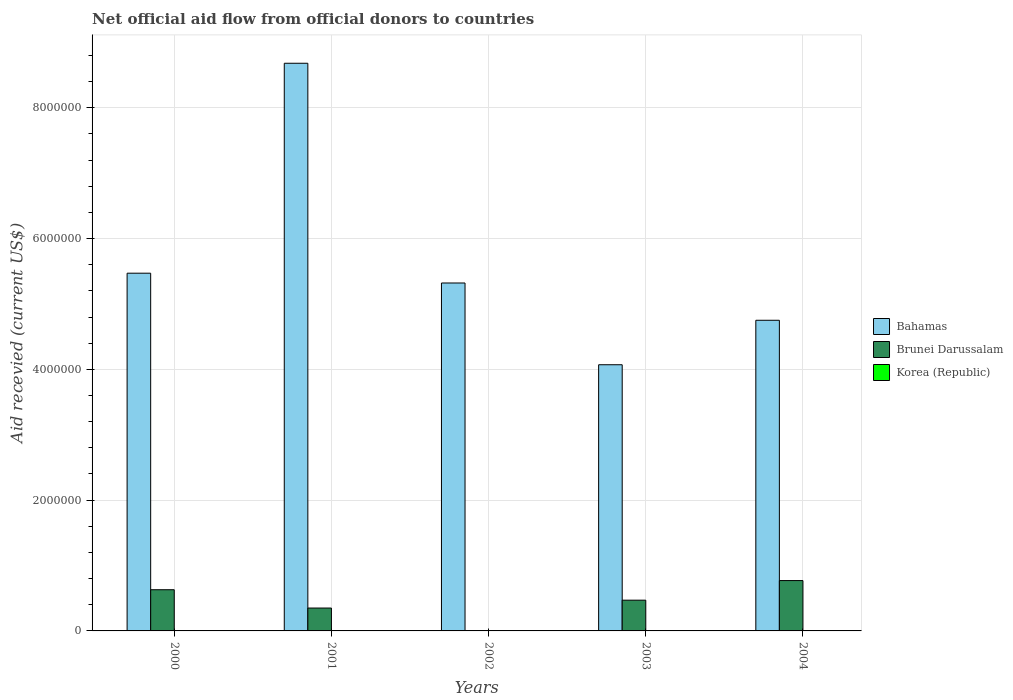How many different coloured bars are there?
Offer a very short reply. 2. Are the number of bars on each tick of the X-axis equal?
Provide a short and direct response. No. How many bars are there on the 1st tick from the left?
Your answer should be very brief. 2. How many bars are there on the 4th tick from the right?
Give a very brief answer. 2. What is the label of the 2nd group of bars from the left?
Your answer should be very brief. 2001. In how many cases, is the number of bars for a given year not equal to the number of legend labels?
Offer a very short reply. 5. What is the total aid received in Korea (Republic) in 2000?
Your answer should be compact. 0. Across all years, what is the maximum total aid received in Bahamas?
Offer a very short reply. 8.68e+06. In which year was the total aid received in Bahamas maximum?
Offer a very short reply. 2001. What is the total total aid received in Korea (Republic) in the graph?
Provide a succinct answer. 0. What is the difference between the total aid received in Korea (Republic) in 2003 and the total aid received in Brunei Darussalam in 2004?
Your answer should be very brief. -7.70e+05. What is the average total aid received in Korea (Republic) per year?
Give a very brief answer. 0. What is the ratio of the total aid received in Brunei Darussalam in 2000 to that in 2001?
Keep it short and to the point. 1.8. Is the total aid received in Bahamas in 2002 less than that in 2003?
Ensure brevity in your answer.  No. Is the difference between the total aid received in Brunei Darussalam in 2001 and 2004 greater than the difference between the total aid received in Bahamas in 2001 and 2004?
Give a very brief answer. No. What is the difference between the highest and the second highest total aid received in Bahamas?
Your response must be concise. 3.21e+06. What is the difference between the highest and the lowest total aid received in Bahamas?
Offer a very short reply. 4.61e+06. In how many years, is the total aid received in Brunei Darussalam greater than the average total aid received in Brunei Darussalam taken over all years?
Offer a very short reply. 3. Is the sum of the total aid received in Bahamas in 2002 and 2004 greater than the maximum total aid received in Korea (Republic) across all years?
Make the answer very short. Yes. Are all the bars in the graph horizontal?
Provide a short and direct response. No. How many years are there in the graph?
Give a very brief answer. 5. Does the graph contain any zero values?
Ensure brevity in your answer.  Yes. Does the graph contain grids?
Offer a terse response. Yes. How are the legend labels stacked?
Your answer should be very brief. Vertical. What is the title of the graph?
Offer a very short reply. Net official aid flow from official donors to countries. Does "Tuvalu" appear as one of the legend labels in the graph?
Your answer should be very brief. No. What is the label or title of the X-axis?
Offer a terse response. Years. What is the label or title of the Y-axis?
Make the answer very short. Aid recevied (current US$). What is the Aid recevied (current US$) of Bahamas in 2000?
Ensure brevity in your answer.  5.47e+06. What is the Aid recevied (current US$) of Brunei Darussalam in 2000?
Your answer should be compact. 6.30e+05. What is the Aid recevied (current US$) of Bahamas in 2001?
Ensure brevity in your answer.  8.68e+06. What is the Aid recevied (current US$) of Brunei Darussalam in 2001?
Make the answer very short. 3.50e+05. What is the Aid recevied (current US$) in Korea (Republic) in 2001?
Make the answer very short. 0. What is the Aid recevied (current US$) of Bahamas in 2002?
Offer a very short reply. 5.32e+06. What is the Aid recevied (current US$) of Korea (Republic) in 2002?
Your answer should be compact. 0. What is the Aid recevied (current US$) of Bahamas in 2003?
Offer a very short reply. 4.07e+06. What is the Aid recevied (current US$) in Korea (Republic) in 2003?
Give a very brief answer. 0. What is the Aid recevied (current US$) in Bahamas in 2004?
Provide a short and direct response. 4.75e+06. What is the Aid recevied (current US$) of Brunei Darussalam in 2004?
Your answer should be compact. 7.70e+05. What is the Aid recevied (current US$) in Korea (Republic) in 2004?
Offer a terse response. 0. Across all years, what is the maximum Aid recevied (current US$) of Bahamas?
Offer a terse response. 8.68e+06. Across all years, what is the maximum Aid recevied (current US$) of Brunei Darussalam?
Your answer should be very brief. 7.70e+05. Across all years, what is the minimum Aid recevied (current US$) in Bahamas?
Give a very brief answer. 4.07e+06. Across all years, what is the minimum Aid recevied (current US$) of Brunei Darussalam?
Your answer should be compact. 0. What is the total Aid recevied (current US$) of Bahamas in the graph?
Ensure brevity in your answer.  2.83e+07. What is the total Aid recevied (current US$) in Brunei Darussalam in the graph?
Your response must be concise. 2.22e+06. What is the total Aid recevied (current US$) in Korea (Republic) in the graph?
Your answer should be compact. 0. What is the difference between the Aid recevied (current US$) of Bahamas in 2000 and that in 2001?
Make the answer very short. -3.21e+06. What is the difference between the Aid recevied (current US$) of Bahamas in 2000 and that in 2002?
Keep it short and to the point. 1.50e+05. What is the difference between the Aid recevied (current US$) of Bahamas in 2000 and that in 2003?
Your response must be concise. 1.40e+06. What is the difference between the Aid recevied (current US$) of Brunei Darussalam in 2000 and that in 2003?
Offer a terse response. 1.60e+05. What is the difference between the Aid recevied (current US$) in Bahamas in 2000 and that in 2004?
Make the answer very short. 7.20e+05. What is the difference between the Aid recevied (current US$) of Brunei Darussalam in 2000 and that in 2004?
Your response must be concise. -1.40e+05. What is the difference between the Aid recevied (current US$) in Bahamas in 2001 and that in 2002?
Provide a succinct answer. 3.36e+06. What is the difference between the Aid recevied (current US$) in Bahamas in 2001 and that in 2003?
Provide a succinct answer. 4.61e+06. What is the difference between the Aid recevied (current US$) in Brunei Darussalam in 2001 and that in 2003?
Offer a terse response. -1.20e+05. What is the difference between the Aid recevied (current US$) of Bahamas in 2001 and that in 2004?
Provide a short and direct response. 3.93e+06. What is the difference between the Aid recevied (current US$) in Brunei Darussalam in 2001 and that in 2004?
Offer a very short reply. -4.20e+05. What is the difference between the Aid recevied (current US$) of Bahamas in 2002 and that in 2003?
Provide a succinct answer. 1.25e+06. What is the difference between the Aid recevied (current US$) of Bahamas in 2002 and that in 2004?
Ensure brevity in your answer.  5.70e+05. What is the difference between the Aid recevied (current US$) of Bahamas in 2003 and that in 2004?
Provide a short and direct response. -6.80e+05. What is the difference between the Aid recevied (current US$) of Bahamas in 2000 and the Aid recevied (current US$) of Brunei Darussalam in 2001?
Ensure brevity in your answer.  5.12e+06. What is the difference between the Aid recevied (current US$) in Bahamas in 2000 and the Aid recevied (current US$) in Brunei Darussalam in 2004?
Your answer should be very brief. 4.70e+06. What is the difference between the Aid recevied (current US$) in Bahamas in 2001 and the Aid recevied (current US$) in Brunei Darussalam in 2003?
Offer a terse response. 8.21e+06. What is the difference between the Aid recevied (current US$) in Bahamas in 2001 and the Aid recevied (current US$) in Brunei Darussalam in 2004?
Offer a very short reply. 7.91e+06. What is the difference between the Aid recevied (current US$) in Bahamas in 2002 and the Aid recevied (current US$) in Brunei Darussalam in 2003?
Your response must be concise. 4.85e+06. What is the difference between the Aid recevied (current US$) of Bahamas in 2002 and the Aid recevied (current US$) of Brunei Darussalam in 2004?
Keep it short and to the point. 4.55e+06. What is the difference between the Aid recevied (current US$) in Bahamas in 2003 and the Aid recevied (current US$) in Brunei Darussalam in 2004?
Give a very brief answer. 3.30e+06. What is the average Aid recevied (current US$) in Bahamas per year?
Your response must be concise. 5.66e+06. What is the average Aid recevied (current US$) in Brunei Darussalam per year?
Your answer should be very brief. 4.44e+05. What is the average Aid recevied (current US$) of Korea (Republic) per year?
Offer a terse response. 0. In the year 2000, what is the difference between the Aid recevied (current US$) in Bahamas and Aid recevied (current US$) in Brunei Darussalam?
Make the answer very short. 4.84e+06. In the year 2001, what is the difference between the Aid recevied (current US$) of Bahamas and Aid recevied (current US$) of Brunei Darussalam?
Provide a succinct answer. 8.33e+06. In the year 2003, what is the difference between the Aid recevied (current US$) of Bahamas and Aid recevied (current US$) of Brunei Darussalam?
Keep it short and to the point. 3.60e+06. In the year 2004, what is the difference between the Aid recevied (current US$) of Bahamas and Aid recevied (current US$) of Brunei Darussalam?
Ensure brevity in your answer.  3.98e+06. What is the ratio of the Aid recevied (current US$) of Bahamas in 2000 to that in 2001?
Your answer should be compact. 0.63. What is the ratio of the Aid recevied (current US$) in Bahamas in 2000 to that in 2002?
Offer a terse response. 1.03. What is the ratio of the Aid recevied (current US$) in Bahamas in 2000 to that in 2003?
Your answer should be compact. 1.34. What is the ratio of the Aid recevied (current US$) in Brunei Darussalam in 2000 to that in 2003?
Provide a succinct answer. 1.34. What is the ratio of the Aid recevied (current US$) of Bahamas in 2000 to that in 2004?
Your answer should be compact. 1.15. What is the ratio of the Aid recevied (current US$) of Brunei Darussalam in 2000 to that in 2004?
Your answer should be very brief. 0.82. What is the ratio of the Aid recevied (current US$) of Bahamas in 2001 to that in 2002?
Offer a very short reply. 1.63. What is the ratio of the Aid recevied (current US$) in Bahamas in 2001 to that in 2003?
Your response must be concise. 2.13. What is the ratio of the Aid recevied (current US$) of Brunei Darussalam in 2001 to that in 2003?
Offer a very short reply. 0.74. What is the ratio of the Aid recevied (current US$) in Bahamas in 2001 to that in 2004?
Your answer should be compact. 1.83. What is the ratio of the Aid recevied (current US$) of Brunei Darussalam in 2001 to that in 2004?
Your answer should be compact. 0.45. What is the ratio of the Aid recevied (current US$) of Bahamas in 2002 to that in 2003?
Offer a terse response. 1.31. What is the ratio of the Aid recevied (current US$) of Bahamas in 2002 to that in 2004?
Provide a succinct answer. 1.12. What is the ratio of the Aid recevied (current US$) in Bahamas in 2003 to that in 2004?
Provide a succinct answer. 0.86. What is the ratio of the Aid recevied (current US$) of Brunei Darussalam in 2003 to that in 2004?
Offer a very short reply. 0.61. What is the difference between the highest and the second highest Aid recevied (current US$) of Bahamas?
Provide a succinct answer. 3.21e+06. What is the difference between the highest and the second highest Aid recevied (current US$) in Brunei Darussalam?
Your answer should be very brief. 1.40e+05. What is the difference between the highest and the lowest Aid recevied (current US$) of Bahamas?
Your answer should be compact. 4.61e+06. What is the difference between the highest and the lowest Aid recevied (current US$) in Brunei Darussalam?
Give a very brief answer. 7.70e+05. 